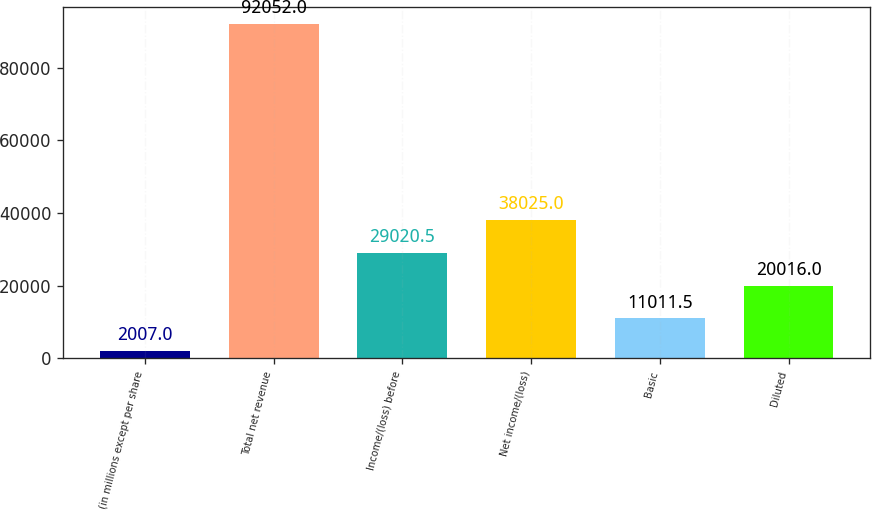<chart> <loc_0><loc_0><loc_500><loc_500><bar_chart><fcel>(in millions except per share<fcel>Total net revenue<fcel>Income/(loss) before<fcel>Net income/(loss)<fcel>Basic<fcel>Diluted<nl><fcel>2007<fcel>92052<fcel>29020.5<fcel>38025<fcel>11011.5<fcel>20016<nl></chart> 